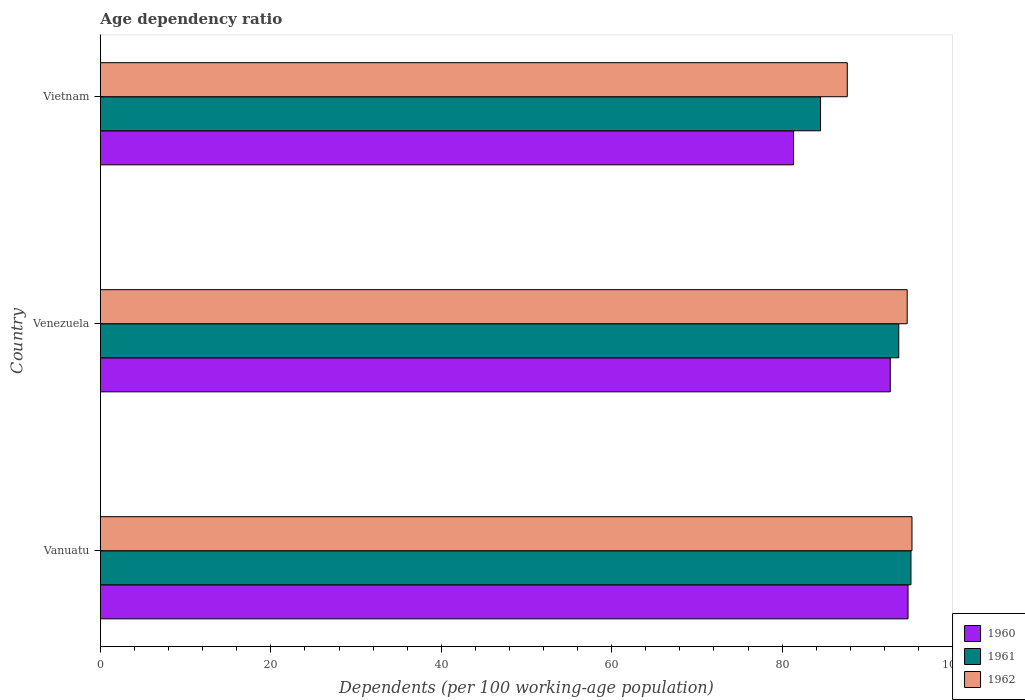How many groups of bars are there?
Offer a very short reply. 3. Are the number of bars per tick equal to the number of legend labels?
Ensure brevity in your answer.  Yes. Are the number of bars on each tick of the Y-axis equal?
Provide a short and direct response. Yes. How many bars are there on the 2nd tick from the top?
Give a very brief answer. 3. How many bars are there on the 1st tick from the bottom?
Offer a terse response. 3. What is the label of the 2nd group of bars from the top?
Your response must be concise. Venezuela. What is the age dependency ratio in in 1960 in Vietnam?
Keep it short and to the point. 81.35. Across all countries, what is the maximum age dependency ratio in in 1962?
Your answer should be compact. 95.24. Across all countries, what is the minimum age dependency ratio in in 1961?
Your response must be concise. 84.51. In which country was the age dependency ratio in in 1960 maximum?
Ensure brevity in your answer.  Vanuatu. In which country was the age dependency ratio in in 1960 minimum?
Your response must be concise. Vietnam. What is the total age dependency ratio in in 1961 in the graph?
Your answer should be very brief. 273.33. What is the difference between the age dependency ratio in in 1960 in Venezuela and that in Vietnam?
Provide a short and direct response. 11.35. What is the difference between the age dependency ratio in in 1962 in Vietnam and the age dependency ratio in in 1960 in Vanuatu?
Keep it short and to the point. -7.13. What is the average age dependency ratio in in 1960 per country?
Provide a short and direct response. 89.61. What is the difference between the age dependency ratio in in 1961 and age dependency ratio in in 1962 in Venezuela?
Keep it short and to the point. -0.99. In how many countries, is the age dependency ratio in in 1962 greater than 88 %?
Your response must be concise. 2. What is the ratio of the age dependency ratio in in 1961 in Venezuela to that in Vietnam?
Make the answer very short. 1.11. Is the age dependency ratio in in 1960 in Vanuatu less than that in Vietnam?
Give a very brief answer. No. Is the difference between the age dependency ratio in in 1961 in Venezuela and Vietnam greater than the difference between the age dependency ratio in in 1962 in Venezuela and Vietnam?
Provide a succinct answer. Yes. What is the difference between the highest and the second highest age dependency ratio in in 1962?
Provide a short and direct response. 0.56. What is the difference between the highest and the lowest age dependency ratio in in 1961?
Give a very brief answer. 10.61. In how many countries, is the age dependency ratio in in 1962 greater than the average age dependency ratio in in 1962 taken over all countries?
Your response must be concise. 2. What does the 1st bar from the top in Vanuatu represents?
Your answer should be very brief. 1962. Is it the case that in every country, the sum of the age dependency ratio in in 1960 and age dependency ratio in in 1961 is greater than the age dependency ratio in in 1962?
Make the answer very short. Yes. Are all the bars in the graph horizontal?
Offer a terse response. Yes. What is the difference between two consecutive major ticks on the X-axis?
Your answer should be very brief. 20. Does the graph contain grids?
Offer a terse response. No. How are the legend labels stacked?
Provide a short and direct response. Vertical. What is the title of the graph?
Give a very brief answer. Age dependency ratio. What is the label or title of the X-axis?
Provide a succinct answer. Dependents (per 100 working-age population). What is the label or title of the Y-axis?
Keep it short and to the point. Country. What is the Dependents (per 100 working-age population) in 1960 in Vanuatu?
Your answer should be very brief. 94.78. What is the Dependents (per 100 working-age population) of 1961 in Vanuatu?
Offer a terse response. 95.12. What is the Dependents (per 100 working-age population) in 1962 in Vanuatu?
Provide a succinct answer. 95.24. What is the Dependents (per 100 working-age population) in 1960 in Venezuela?
Provide a succinct answer. 92.7. What is the Dependents (per 100 working-age population) of 1961 in Venezuela?
Make the answer very short. 93.69. What is the Dependents (per 100 working-age population) in 1962 in Venezuela?
Your answer should be very brief. 94.68. What is the Dependents (per 100 working-age population) of 1960 in Vietnam?
Your answer should be very brief. 81.35. What is the Dependents (per 100 working-age population) of 1961 in Vietnam?
Keep it short and to the point. 84.51. What is the Dependents (per 100 working-age population) of 1962 in Vietnam?
Provide a succinct answer. 87.65. Across all countries, what is the maximum Dependents (per 100 working-age population) in 1960?
Your answer should be very brief. 94.78. Across all countries, what is the maximum Dependents (per 100 working-age population) of 1961?
Provide a short and direct response. 95.12. Across all countries, what is the maximum Dependents (per 100 working-age population) in 1962?
Provide a succinct answer. 95.24. Across all countries, what is the minimum Dependents (per 100 working-age population) in 1960?
Give a very brief answer. 81.35. Across all countries, what is the minimum Dependents (per 100 working-age population) of 1961?
Ensure brevity in your answer.  84.51. Across all countries, what is the minimum Dependents (per 100 working-age population) of 1962?
Provide a succinct answer. 87.65. What is the total Dependents (per 100 working-age population) of 1960 in the graph?
Keep it short and to the point. 268.82. What is the total Dependents (per 100 working-age population) of 1961 in the graph?
Offer a very short reply. 273.33. What is the total Dependents (per 100 working-age population) in 1962 in the graph?
Provide a short and direct response. 277.57. What is the difference between the Dependents (per 100 working-age population) in 1960 in Vanuatu and that in Venezuela?
Your response must be concise. 2.08. What is the difference between the Dependents (per 100 working-age population) of 1961 in Vanuatu and that in Venezuela?
Provide a short and direct response. 1.43. What is the difference between the Dependents (per 100 working-age population) in 1962 in Vanuatu and that in Venezuela?
Keep it short and to the point. 0.56. What is the difference between the Dependents (per 100 working-age population) in 1960 in Vanuatu and that in Vietnam?
Keep it short and to the point. 13.43. What is the difference between the Dependents (per 100 working-age population) of 1961 in Vanuatu and that in Vietnam?
Offer a very short reply. 10.61. What is the difference between the Dependents (per 100 working-age population) in 1962 in Vanuatu and that in Vietnam?
Offer a terse response. 7.59. What is the difference between the Dependents (per 100 working-age population) in 1960 in Venezuela and that in Vietnam?
Provide a succinct answer. 11.35. What is the difference between the Dependents (per 100 working-age population) in 1961 in Venezuela and that in Vietnam?
Offer a terse response. 9.18. What is the difference between the Dependents (per 100 working-age population) of 1962 in Venezuela and that in Vietnam?
Make the answer very short. 7.03. What is the difference between the Dependents (per 100 working-age population) of 1960 in Vanuatu and the Dependents (per 100 working-age population) of 1961 in Venezuela?
Provide a succinct answer. 1.09. What is the difference between the Dependents (per 100 working-age population) in 1960 in Vanuatu and the Dependents (per 100 working-age population) in 1962 in Venezuela?
Keep it short and to the point. 0.1. What is the difference between the Dependents (per 100 working-age population) of 1961 in Vanuatu and the Dependents (per 100 working-age population) of 1962 in Venezuela?
Offer a very short reply. 0.44. What is the difference between the Dependents (per 100 working-age population) in 1960 in Vanuatu and the Dependents (per 100 working-age population) in 1961 in Vietnam?
Provide a short and direct response. 10.27. What is the difference between the Dependents (per 100 working-age population) of 1960 in Vanuatu and the Dependents (per 100 working-age population) of 1962 in Vietnam?
Your response must be concise. 7.13. What is the difference between the Dependents (per 100 working-age population) of 1961 in Vanuatu and the Dependents (per 100 working-age population) of 1962 in Vietnam?
Your answer should be very brief. 7.47. What is the difference between the Dependents (per 100 working-age population) in 1960 in Venezuela and the Dependents (per 100 working-age population) in 1961 in Vietnam?
Give a very brief answer. 8.18. What is the difference between the Dependents (per 100 working-age population) of 1960 in Venezuela and the Dependents (per 100 working-age population) of 1962 in Vietnam?
Give a very brief answer. 5.05. What is the difference between the Dependents (per 100 working-age population) of 1961 in Venezuela and the Dependents (per 100 working-age population) of 1962 in Vietnam?
Provide a short and direct response. 6.04. What is the average Dependents (per 100 working-age population) of 1960 per country?
Provide a succinct answer. 89.61. What is the average Dependents (per 100 working-age population) in 1961 per country?
Your answer should be very brief. 91.11. What is the average Dependents (per 100 working-age population) in 1962 per country?
Your answer should be very brief. 92.52. What is the difference between the Dependents (per 100 working-age population) in 1960 and Dependents (per 100 working-age population) in 1961 in Vanuatu?
Give a very brief answer. -0.34. What is the difference between the Dependents (per 100 working-age population) of 1960 and Dependents (per 100 working-age population) of 1962 in Vanuatu?
Ensure brevity in your answer.  -0.46. What is the difference between the Dependents (per 100 working-age population) of 1961 and Dependents (per 100 working-age population) of 1962 in Vanuatu?
Your answer should be very brief. -0.12. What is the difference between the Dependents (per 100 working-age population) in 1960 and Dependents (per 100 working-age population) in 1961 in Venezuela?
Offer a terse response. -1. What is the difference between the Dependents (per 100 working-age population) of 1960 and Dependents (per 100 working-age population) of 1962 in Venezuela?
Your response must be concise. -1.99. What is the difference between the Dependents (per 100 working-age population) of 1961 and Dependents (per 100 working-age population) of 1962 in Venezuela?
Keep it short and to the point. -0.99. What is the difference between the Dependents (per 100 working-age population) of 1960 and Dependents (per 100 working-age population) of 1961 in Vietnam?
Provide a short and direct response. -3.17. What is the difference between the Dependents (per 100 working-age population) of 1960 and Dependents (per 100 working-age population) of 1962 in Vietnam?
Offer a terse response. -6.3. What is the difference between the Dependents (per 100 working-age population) of 1961 and Dependents (per 100 working-age population) of 1962 in Vietnam?
Your answer should be very brief. -3.14. What is the ratio of the Dependents (per 100 working-age population) of 1960 in Vanuatu to that in Venezuela?
Provide a short and direct response. 1.02. What is the ratio of the Dependents (per 100 working-age population) in 1961 in Vanuatu to that in Venezuela?
Offer a terse response. 1.02. What is the ratio of the Dependents (per 100 working-age population) in 1962 in Vanuatu to that in Venezuela?
Your answer should be compact. 1.01. What is the ratio of the Dependents (per 100 working-age population) of 1960 in Vanuatu to that in Vietnam?
Make the answer very short. 1.17. What is the ratio of the Dependents (per 100 working-age population) of 1961 in Vanuatu to that in Vietnam?
Ensure brevity in your answer.  1.13. What is the ratio of the Dependents (per 100 working-age population) in 1962 in Vanuatu to that in Vietnam?
Keep it short and to the point. 1.09. What is the ratio of the Dependents (per 100 working-age population) in 1960 in Venezuela to that in Vietnam?
Your response must be concise. 1.14. What is the ratio of the Dependents (per 100 working-age population) in 1961 in Venezuela to that in Vietnam?
Offer a terse response. 1.11. What is the ratio of the Dependents (per 100 working-age population) of 1962 in Venezuela to that in Vietnam?
Your answer should be very brief. 1.08. What is the difference between the highest and the second highest Dependents (per 100 working-age population) of 1960?
Provide a short and direct response. 2.08. What is the difference between the highest and the second highest Dependents (per 100 working-age population) of 1961?
Your answer should be very brief. 1.43. What is the difference between the highest and the second highest Dependents (per 100 working-age population) of 1962?
Make the answer very short. 0.56. What is the difference between the highest and the lowest Dependents (per 100 working-age population) in 1960?
Provide a succinct answer. 13.43. What is the difference between the highest and the lowest Dependents (per 100 working-age population) of 1961?
Provide a short and direct response. 10.61. What is the difference between the highest and the lowest Dependents (per 100 working-age population) of 1962?
Provide a succinct answer. 7.59. 